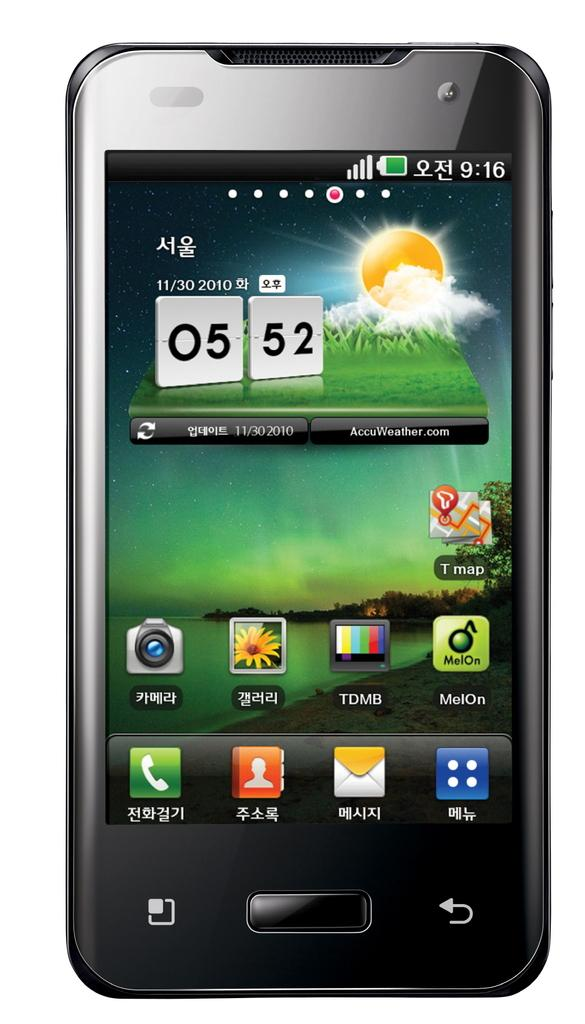<image>
Give a short and clear explanation of the subsequent image. An Asian brand of smartphone displays its home screen featuring the time 05:52 on 11/30/2010. 